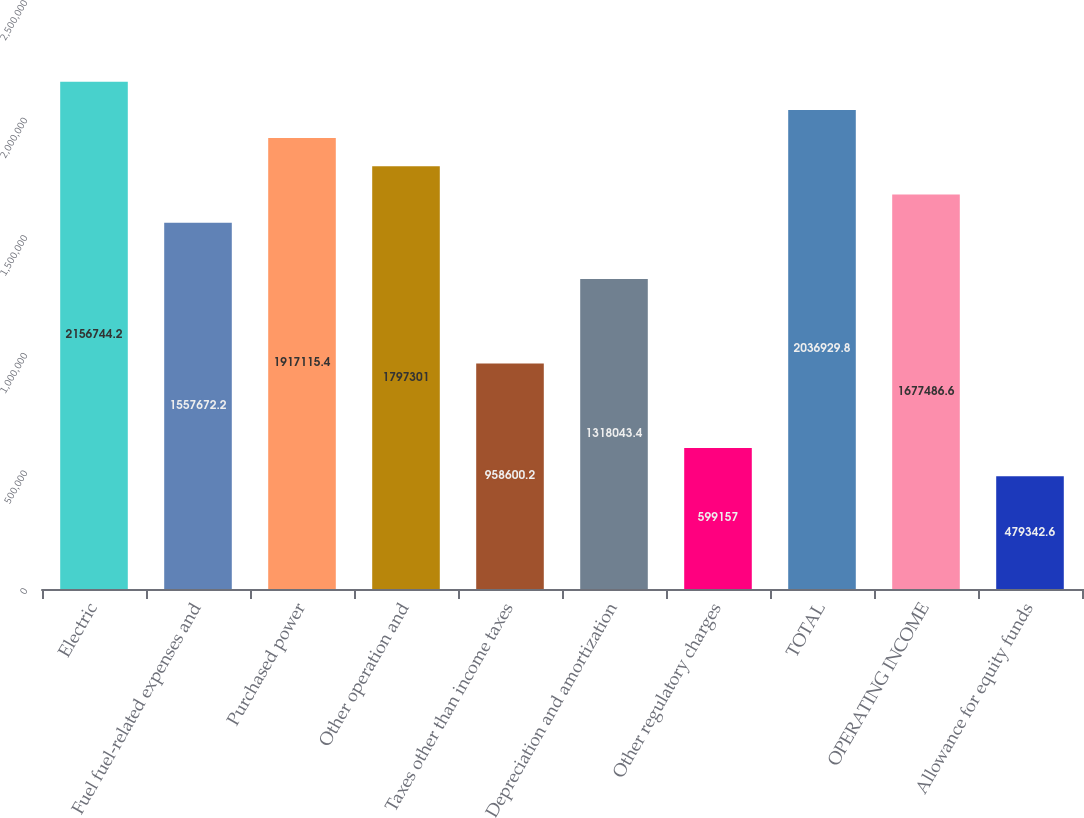Convert chart. <chart><loc_0><loc_0><loc_500><loc_500><bar_chart><fcel>Electric<fcel>Fuel fuel-related expenses and<fcel>Purchased power<fcel>Other operation and<fcel>Taxes other than income taxes<fcel>Depreciation and amortization<fcel>Other regulatory charges<fcel>TOTAL<fcel>OPERATING INCOME<fcel>Allowance for equity funds<nl><fcel>2.15674e+06<fcel>1.55767e+06<fcel>1.91712e+06<fcel>1.7973e+06<fcel>958600<fcel>1.31804e+06<fcel>599157<fcel>2.03693e+06<fcel>1.67749e+06<fcel>479343<nl></chart> 